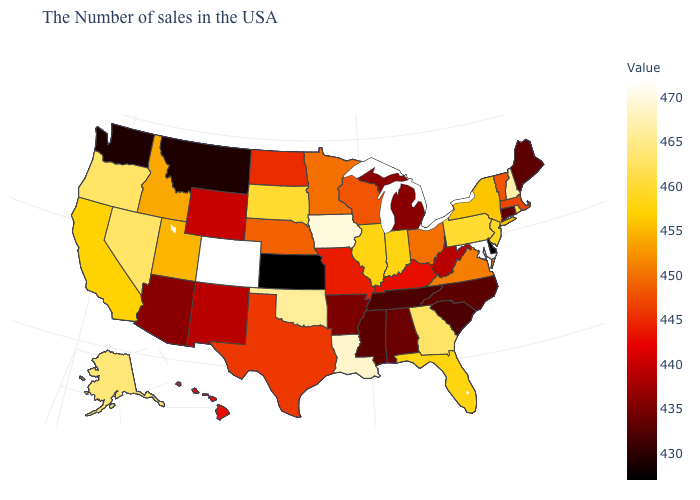Is the legend a continuous bar?
Answer briefly. Yes. Does Maryland have the highest value in the USA?
Keep it brief. Yes. Does Iowa have the highest value in the MidWest?
Give a very brief answer. Yes. Does West Virginia have the highest value in the South?
Short answer required. No. Which states have the lowest value in the USA?
Keep it brief. Delaware, Kansas. Among the states that border North Dakota , which have the highest value?
Be succinct. South Dakota. Which states have the lowest value in the West?
Concise answer only. Montana, Washington. Does Colorado have the highest value in the USA?
Give a very brief answer. Yes. Which states have the lowest value in the USA?
Write a very short answer. Delaware, Kansas. 